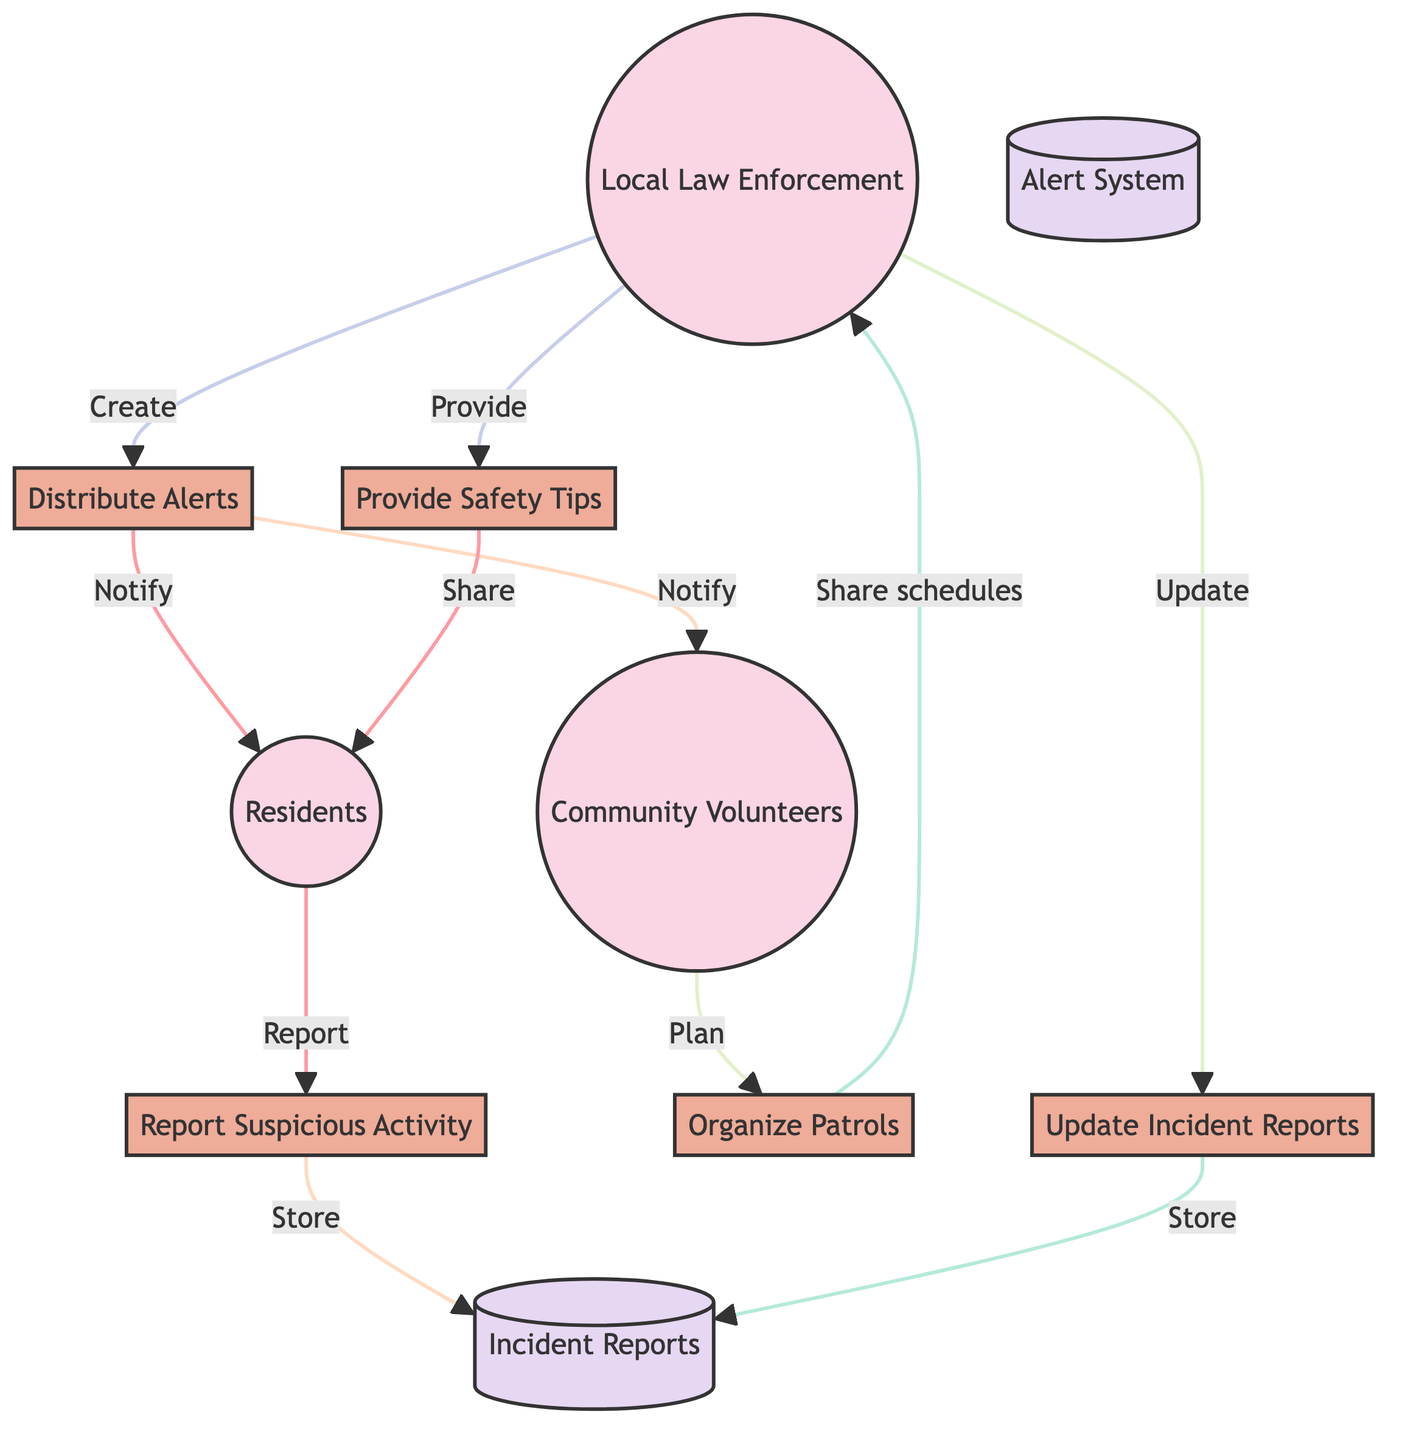What are the three main entities in the diagram? The three main entities identified in the diagram are Residents, Local Law Enforcement, and Community Volunteers. These are the participants involved in the Neighbourhood Watch Program.
Answer: Residents, Local Law Enforcement, Community Volunteers How many processes are depicted in the diagram? The diagram illustrates five processes: Report Suspicious Activity, Distribute Alerts, Organize Patrols, Update Incident Reports, and Provide Safety Tips. By counting each labeled process node, we find that there are five.
Answer: 5 What information do residents provide to the "Report Suspicious Activity" process? Residents provide information about unusual or suspicious activities they observe to the "Report Suspicious Activity" process. This flow of information is crucial for identifying potential issues in the neighbourhood.
Answer: Unusual or suspicious activities Which process is responsible for updating the incident reports? The "Update Incident Reports" process is responsible for updating the incident reports database with new information gathered by local law enforcement about reported incidents.
Answer: Update Incident Reports How many data stores are present in the diagram? The diagram contains two data stores: Incident Reports and Alert System. By directly examining the diagram's data store nodes, we can confirm there are two.
Answer: 2 What are the recipients of alerts from the "Distribute Alerts" process? The recipients of alerts from the "Distribute Alerts" process are Residents and Community Volunteers, as the arrows show that alerts are sent to both entities directly from this process.
Answer: Residents, Community Volunteers What type of information do community volunteers provide to the "Organize Patrols" process? Community volunteers provide information related to planning and organizing patrols in the neighbourhood to the "Organize Patrols" process, contributing to enhanced safety efforts.
Answer: Planning and organizing patrols Which entity receives safety tips from local law enforcement? Residents receive safety tips from local law enforcement through the "Provide Safety Tips" process, as indicated by the flow direction from local law enforcement to residents in the diagram.
Answer: Residents What information flows from "Organize Patrols" to local law enforcement? The flow from "Organize Patrols" to local law enforcement consists of details concerning patrol schedules and reports, which are important for maintaining communication about community safety efforts.
Answer: Patrol schedules and reports 